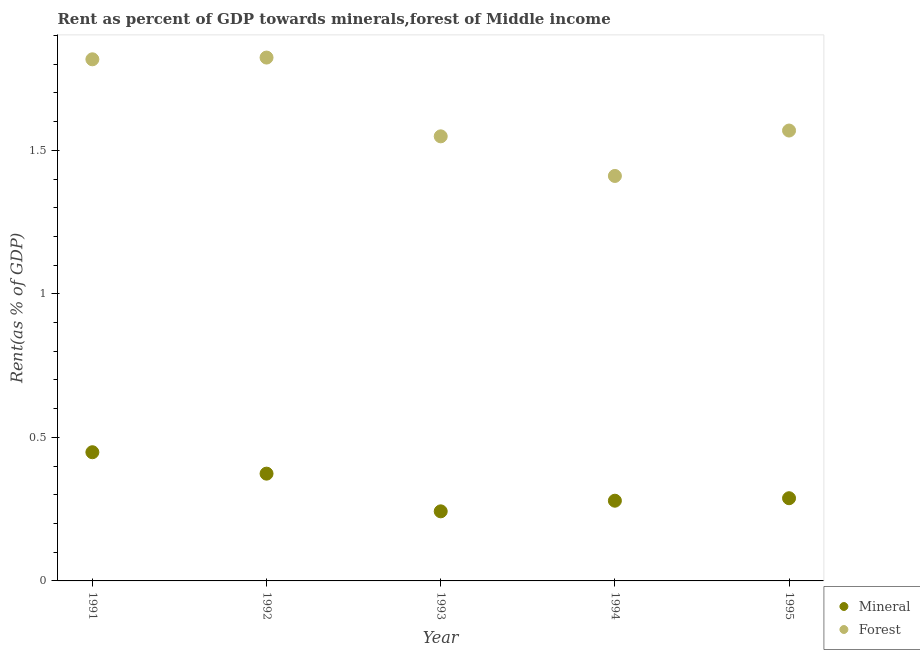What is the mineral rent in 1995?
Make the answer very short. 0.29. Across all years, what is the maximum forest rent?
Provide a short and direct response. 1.82. Across all years, what is the minimum forest rent?
Keep it short and to the point. 1.41. In which year was the mineral rent minimum?
Your response must be concise. 1993. What is the total mineral rent in the graph?
Offer a very short reply. 1.63. What is the difference between the forest rent in 1992 and that in 1995?
Provide a succinct answer. 0.25. What is the difference between the forest rent in 1994 and the mineral rent in 1991?
Keep it short and to the point. 0.96. What is the average mineral rent per year?
Your response must be concise. 0.33. In the year 1991, what is the difference between the mineral rent and forest rent?
Provide a short and direct response. -1.37. What is the ratio of the forest rent in 1991 to that in 1995?
Make the answer very short. 1.16. Is the mineral rent in 1992 less than that in 1995?
Your response must be concise. No. What is the difference between the highest and the second highest mineral rent?
Keep it short and to the point. 0.07. What is the difference between the highest and the lowest mineral rent?
Provide a succinct answer. 0.21. In how many years, is the forest rent greater than the average forest rent taken over all years?
Make the answer very short. 2. Does the forest rent monotonically increase over the years?
Offer a terse response. No. Is the forest rent strictly greater than the mineral rent over the years?
Ensure brevity in your answer.  Yes. Is the forest rent strictly less than the mineral rent over the years?
Keep it short and to the point. No. How many dotlines are there?
Make the answer very short. 2. What is the difference between two consecutive major ticks on the Y-axis?
Ensure brevity in your answer.  0.5. Are the values on the major ticks of Y-axis written in scientific E-notation?
Your response must be concise. No. Does the graph contain any zero values?
Provide a succinct answer. No. How many legend labels are there?
Keep it short and to the point. 2. How are the legend labels stacked?
Offer a terse response. Vertical. What is the title of the graph?
Your response must be concise. Rent as percent of GDP towards minerals,forest of Middle income. What is the label or title of the Y-axis?
Keep it short and to the point. Rent(as % of GDP). What is the Rent(as % of GDP) in Mineral in 1991?
Make the answer very short. 0.45. What is the Rent(as % of GDP) in Forest in 1991?
Your answer should be very brief. 1.82. What is the Rent(as % of GDP) in Mineral in 1992?
Offer a terse response. 0.37. What is the Rent(as % of GDP) of Forest in 1992?
Offer a terse response. 1.82. What is the Rent(as % of GDP) in Mineral in 1993?
Your response must be concise. 0.24. What is the Rent(as % of GDP) in Forest in 1993?
Provide a short and direct response. 1.55. What is the Rent(as % of GDP) in Mineral in 1994?
Offer a very short reply. 0.28. What is the Rent(as % of GDP) in Forest in 1994?
Provide a short and direct response. 1.41. What is the Rent(as % of GDP) of Mineral in 1995?
Ensure brevity in your answer.  0.29. What is the Rent(as % of GDP) in Forest in 1995?
Offer a terse response. 1.57. Across all years, what is the maximum Rent(as % of GDP) in Mineral?
Your answer should be very brief. 0.45. Across all years, what is the maximum Rent(as % of GDP) of Forest?
Ensure brevity in your answer.  1.82. Across all years, what is the minimum Rent(as % of GDP) in Mineral?
Give a very brief answer. 0.24. Across all years, what is the minimum Rent(as % of GDP) of Forest?
Provide a short and direct response. 1.41. What is the total Rent(as % of GDP) of Mineral in the graph?
Your answer should be very brief. 1.63. What is the total Rent(as % of GDP) of Forest in the graph?
Make the answer very short. 8.17. What is the difference between the Rent(as % of GDP) of Mineral in 1991 and that in 1992?
Make the answer very short. 0.07. What is the difference between the Rent(as % of GDP) in Forest in 1991 and that in 1992?
Offer a terse response. -0.01. What is the difference between the Rent(as % of GDP) in Mineral in 1991 and that in 1993?
Keep it short and to the point. 0.21. What is the difference between the Rent(as % of GDP) of Forest in 1991 and that in 1993?
Make the answer very short. 0.27. What is the difference between the Rent(as % of GDP) of Mineral in 1991 and that in 1994?
Your answer should be compact. 0.17. What is the difference between the Rent(as % of GDP) in Forest in 1991 and that in 1994?
Keep it short and to the point. 0.41. What is the difference between the Rent(as % of GDP) in Mineral in 1991 and that in 1995?
Make the answer very short. 0.16. What is the difference between the Rent(as % of GDP) in Forest in 1991 and that in 1995?
Provide a succinct answer. 0.25. What is the difference between the Rent(as % of GDP) of Mineral in 1992 and that in 1993?
Offer a terse response. 0.13. What is the difference between the Rent(as % of GDP) in Forest in 1992 and that in 1993?
Provide a short and direct response. 0.27. What is the difference between the Rent(as % of GDP) in Mineral in 1992 and that in 1994?
Provide a succinct answer. 0.09. What is the difference between the Rent(as % of GDP) in Forest in 1992 and that in 1994?
Keep it short and to the point. 0.41. What is the difference between the Rent(as % of GDP) of Mineral in 1992 and that in 1995?
Give a very brief answer. 0.09. What is the difference between the Rent(as % of GDP) of Forest in 1992 and that in 1995?
Make the answer very short. 0.25. What is the difference between the Rent(as % of GDP) in Mineral in 1993 and that in 1994?
Offer a very short reply. -0.04. What is the difference between the Rent(as % of GDP) in Forest in 1993 and that in 1994?
Offer a terse response. 0.14. What is the difference between the Rent(as % of GDP) of Mineral in 1993 and that in 1995?
Your answer should be very brief. -0.05. What is the difference between the Rent(as % of GDP) of Forest in 1993 and that in 1995?
Your response must be concise. -0.02. What is the difference between the Rent(as % of GDP) in Mineral in 1994 and that in 1995?
Offer a terse response. -0.01. What is the difference between the Rent(as % of GDP) of Forest in 1994 and that in 1995?
Make the answer very short. -0.16. What is the difference between the Rent(as % of GDP) of Mineral in 1991 and the Rent(as % of GDP) of Forest in 1992?
Provide a short and direct response. -1.38. What is the difference between the Rent(as % of GDP) in Mineral in 1991 and the Rent(as % of GDP) in Forest in 1993?
Keep it short and to the point. -1.1. What is the difference between the Rent(as % of GDP) in Mineral in 1991 and the Rent(as % of GDP) in Forest in 1994?
Provide a succinct answer. -0.96. What is the difference between the Rent(as % of GDP) of Mineral in 1991 and the Rent(as % of GDP) of Forest in 1995?
Make the answer very short. -1.12. What is the difference between the Rent(as % of GDP) of Mineral in 1992 and the Rent(as % of GDP) of Forest in 1993?
Ensure brevity in your answer.  -1.18. What is the difference between the Rent(as % of GDP) in Mineral in 1992 and the Rent(as % of GDP) in Forest in 1994?
Your answer should be very brief. -1.04. What is the difference between the Rent(as % of GDP) in Mineral in 1992 and the Rent(as % of GDP) in Forest in 1995?
Offer a very short reply. -1.2. What is the difference between the Rent(as % of GDP) in Mineral in 1993 and the Rent(as % of GDP) in Forest in 1994?
Ensure brevity in your answer.  -1.17. What is the difference between the Rent(as % of GDP) of Mineral in 1993 and the Rent(as % of GDP) of Forest in 1995?
Give a very brief answer. -1.33. What is the difference between the Rent(as % of GDP) in Mineral in 1994 and the Rent(as % of GDP) in Forest in 1995?
Make the answer very short. -1.29. What is the average Rent(as % of GDP) of Mineral per year?
Keep it short and to the point. 0.33. What is the average Rent(as % of GDP) in Forest per year?
Provide a short and direct response. 1.63. In the year 1991, what is the difference between the Rent(as % of GDP) of Mineral and Rent(as % of GDP) of Forest?
Ensure brevity in your answer.  -1.37. In the year 1992, what is the difference between the Rent(as % of GDP) of Mineral and Rent(as % of GDP) of Forest?
Give a very brief answer. -1.45. In the year 1993, what is the difference between the Rent(as % of GDP) of Mineral and Rent(as % of GDP) of Forest?
Provide a short and direct response. -1.31. In the year 1994, what is the difference between the Rent(as % of GDP) in Mineral and Rent(as % of GDP) in Forest?
Give a very brief answer. -1.13. In the year 1995, what is the difference between the Rent(as % of GDP) in Mineral and Rent(as % of GDP) in Forest?
Make the answer very short. -1.28. What is the ratio of the Rent(as % of GDP) in Mineral in 1991 to that in 1992?
Offer a very short reply. 1.2. What is the ratio of the Rent(as % of GDP) in Forest in 1991 to that in 1992?
Ensure brevity in your answer.  1. What is the ratio of the Rent(as % of GDP) in Mineral in 1991 to that in 1993?
Your answer should be compact. 1.85. What is the ratio of the Rent(as % of GDP) of Forest in 1991 to that in 1993?
Offer a terse response. 1.17. What is the ratio of the Rent(as % of GDP) in Mineral in 1991 to that in 1994?
Make the answer very short. 1.6. What is the ratio of the Rent(as % of GDP) in Forest in 1991 to that in 1994?
Give a very brief answer. 1.29. What is the ratio of the Rent(as % of GDP) in Mineral in 1991 to that in 1995?
Your answer should be very brief. 1.56. What is the ratio of the Rent(as % of GDP) of Forest in 1991 to that in 1995?
Give a very brief answer. 1.16. What is the ratio of the Rent(as % of GDP) in Mineral in 1992 to that in 1993?
Offer a very short reply. 1.54. What is the ratio of the Rent(as % of GDP) of Forest in 1992 to that in 1993?
Provide a short and direct response. 1.18. What is the ratio of the Rent(as % of GDP) of Mineral in 1992 to that in 1994?
Your answer should be very brief. 1.34. What is the ratio of the Rent(as % of GDP) in Forest in 1992 to that in 1994?
Give a very brief answer. 1.29. What is the ratio of the Rent(as % of GDP) in Mineral in 1992 to that in 1995?
Your answer should be very brief. 1.3. What is the ratio of the Rent(as % of GDP) of Forest in 1992 to that in 1995?
Give a very brief answer. 1.16. What is the ratio of the Rent(as % of GDP) of Mineral in 1993 to that in 1994?
Offer a terse response. 0.87. What is the ratio of the Rent(as % of GDP) in Forest in 1993 to that in 1994?
Your answer should be compact. 1.1. What is the ratio of the Rent(as % of GDP) of Mineral in 1993 to that in 1995?
Ensure brevity in your answer.  0.84. What is the ratio of the Rent(as % of GDP) of Forest in 1993 to that in 1995?
Offer a terse response. 0.99. What is the ratio of the Rent(as % of GDP) of Mineral in 1994 to that in 1995?
Your answer should be very brief. 0.97. What is the ratio of the Rent(as % of GDP) of Forest in 1994 to that in 1995?
Offer a very short reply. 0.9. What is the difference between the highest and the second highest Rent(as % of GDP) in Mineral?
Make the answer very short. 0.07. What is the difference between the highest and the second highest Rent(as % of GDP) of Forest?
Your answer should be very brief. 0.01. What is the difference between the highest and the lowest Rent(as % of GDP) of Mineral?
Give a very brief answer. 0.21. What is the difference between the highest and the lowest Rent(as % of GDP) of Forest?
Provide a short and direct response. 0.41. 